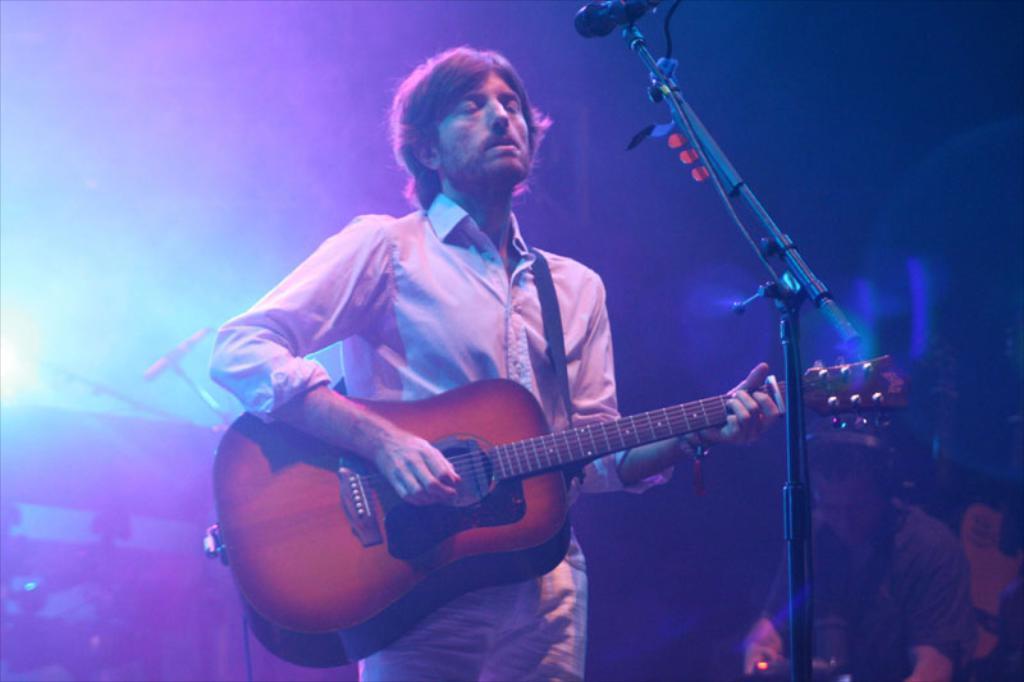How would you summarize this image in a sentence or two? In this picture we can see man wearing a white shirt is playing a guitar in the studio, in front he has a microphone stand and man beside him listing his song on the headphone. 